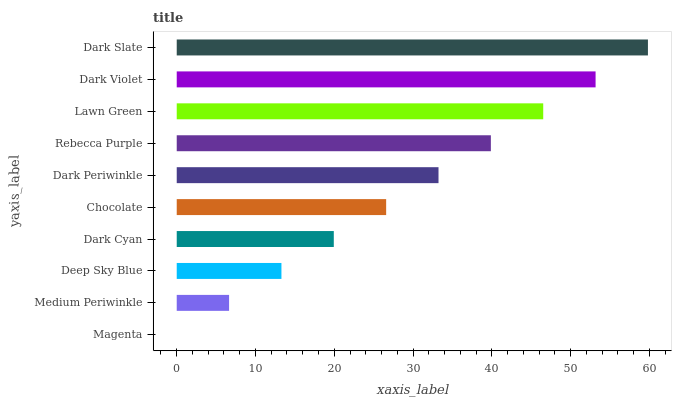Is Magenta the minimum?
Answer yes or no. Yes. Is Dark Slate the maximum?
Answer yes or no. Yes. Is Medium Periwinkle the minimum?
Answer yes or no. No. Is Medium Periwinkle the maximum?
Answer yes or no. No. Is Medium Periwinkle greater than Magenta?
Answer yes or no. Yes. Is Magenta less than Medium Periwinkle?
Answer yes or no. Yes. Is Magenta greater than Medium Periwinkle?
Answer yes or no. No. Is Medium Periwinkle less than Magenta?
Answer yes or no. No. Is Dark Periwinkle the high median?
Answer yes or no. Yes. Is Chocolate the low median?
Answer yes or no. Yes. Is Magenta the high median?
Answer yes or no. No. Is Dark Cyan the low median?
Answer yes or no. No. 